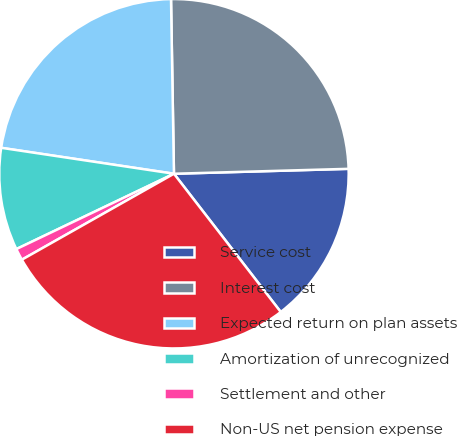<chart> <loc_0><loc_0><loc_500><loc_500><pie_chart><fcel>Service cost<fcel>Interest cost<fcel>Expected return on plan assets<fcel>Amortization of unrecognized<fcel>Settlement and other<fcel>Non-US net pension expense<nl><fcel>14.98%<fcel>24.82%<fcel>22.36%<fcel>9.47%<fcel>1.09%<fcel>27.28%<nl></chart> 